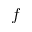Convert formula to latex. <formula><loc_0><loc_0><loc_500><loc_500>f</formula> 